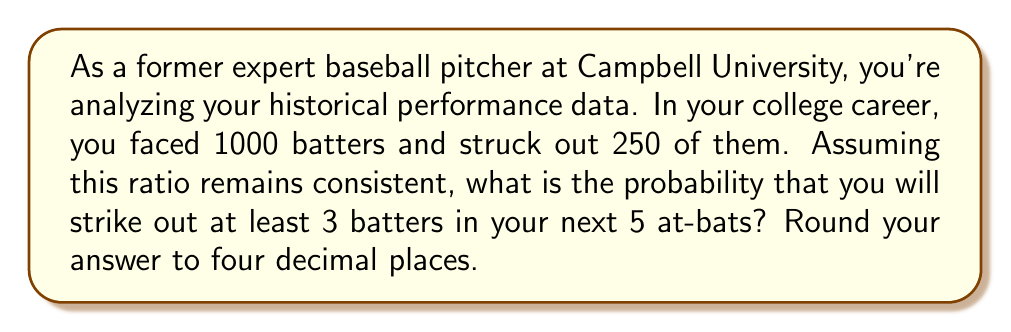Solve this math problem. Let's approach this step-by-step:

1) First, we need to calculate the probability of striking out a single batter:
   $p = \frac{250}{1000} = 0.25$ or 25%

2) The probability of not striking out a batter is:
   $q = 1 - p = 0.75$ or 75%

3) We want to find the probability of striking out at least 3 batters in 5 at-bats. This is equivalent to the probability of striking out 3, 4, or 5 batters.

4) We can use the binomial probability formula:

   $P(X = k) = \binom{n}{k} p^k q^{n-k}$

   Where $n$ is the number of trials (5 in this case), $k$ is the number of successes, $p$ is the probability of success on a single trial, and $q$ is the probability of failure on a single trial.

5) We need to calculate:
   $P(X \geq 3) = P(X = 3) + P(X = 4) + P(X = 5)$

6) Let's calculate each term:

   $P(X = 3) = \binom{5}{3} (0.25)^3 (0.75)^2 = 10 \cdot 0.015625 \cdot 0.5625 = 0.087890625$
   
   $P(X = 4) = \binom{5}{4} (0.25)^4 (0.75)^1 = 5 \cdot 0.00390625 \cdot 0.75 = 0.0146484375$
   
   $P(X = 5) = \binom{5}{5} (0.25)^5 (0.75)^0 = 1 \cdot 0.0009765625 \cdot 1 = 0.0009765625$

7) Now, we sum these probabilities:

   $P(X \geq 3) = 0.087890625 + 0.0146484375 + 0.0009765625 = 0.1035156250$

8) Rounding to four decimal places:

   $P(X \geq 3) \approx 0.1035$
Answer: 0.1035 